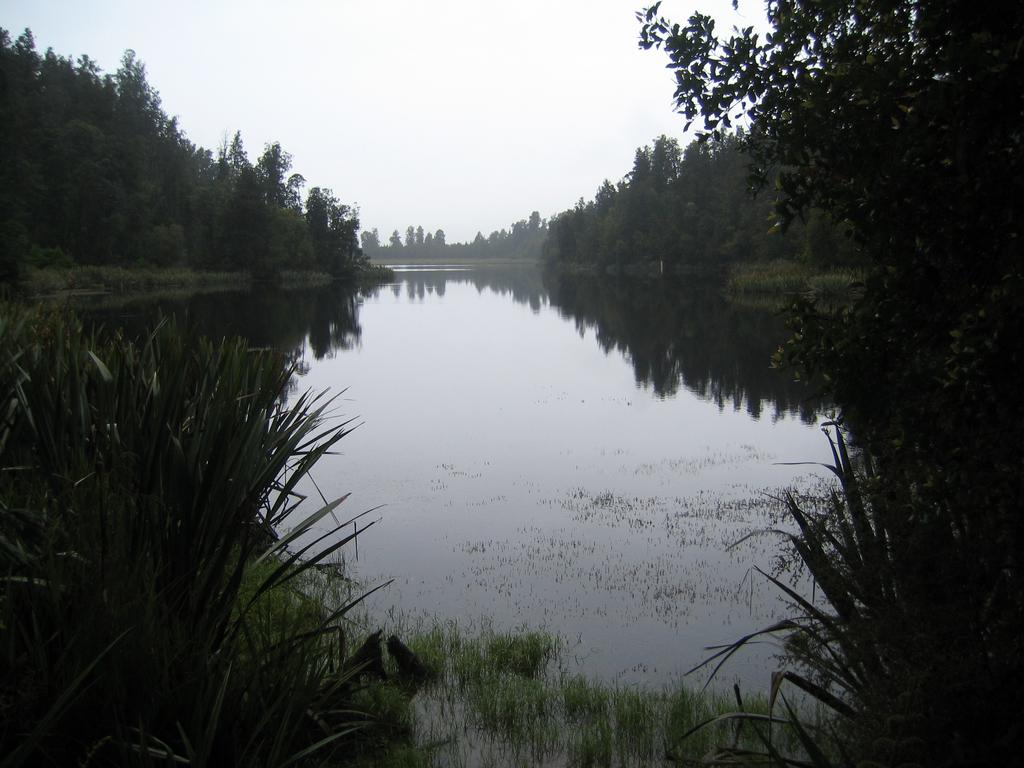What type of vegetation can be seen in the image? There are trees in the image. What else can be seen on the ground in the image? There is grass in the image. What is visible in the image besides the vegetation? There is water visible in the image. What is visible at the top of the image? The sky is visible at the top of the image. What type of letter is being shaken by the wrist in the image? There is no wrist, letter, or shaking motion present in the image. 